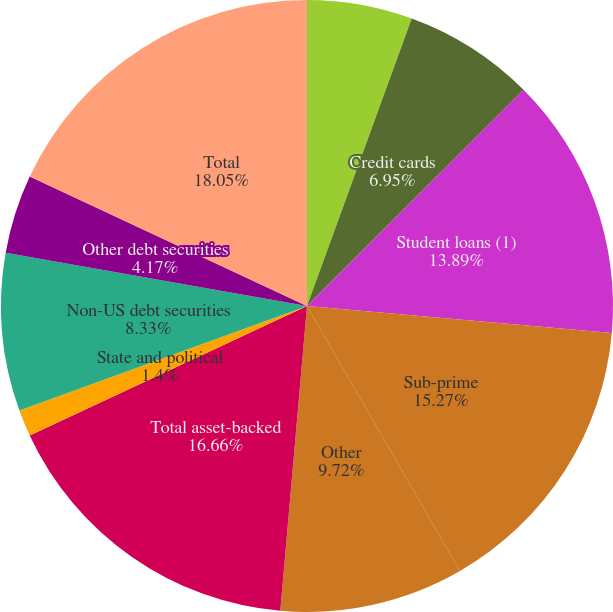Convert chart to OTSL. <chart><loc_0><loc_0><loc_500><loc_500><pie_chart><fcel>Mortgage-backed securities<fcel>Credit cards<fcel>Student loans (1)<fcel>Sub-prime<fcel>Other<fcel>Total asset-backed<fcel>State and political<fcel>Non-US debt securities<fcel>Other debt securities<fcel>Total<nl><fcel>5.56%<fcel>6.95%<fcel>13.89%<fcel>15.27%<fcel>9.72%<fcel>16.66%<fcel>1.4%<fcel>8.33%<fcel>4.17%<fcel>18.05%<nl></chart> 